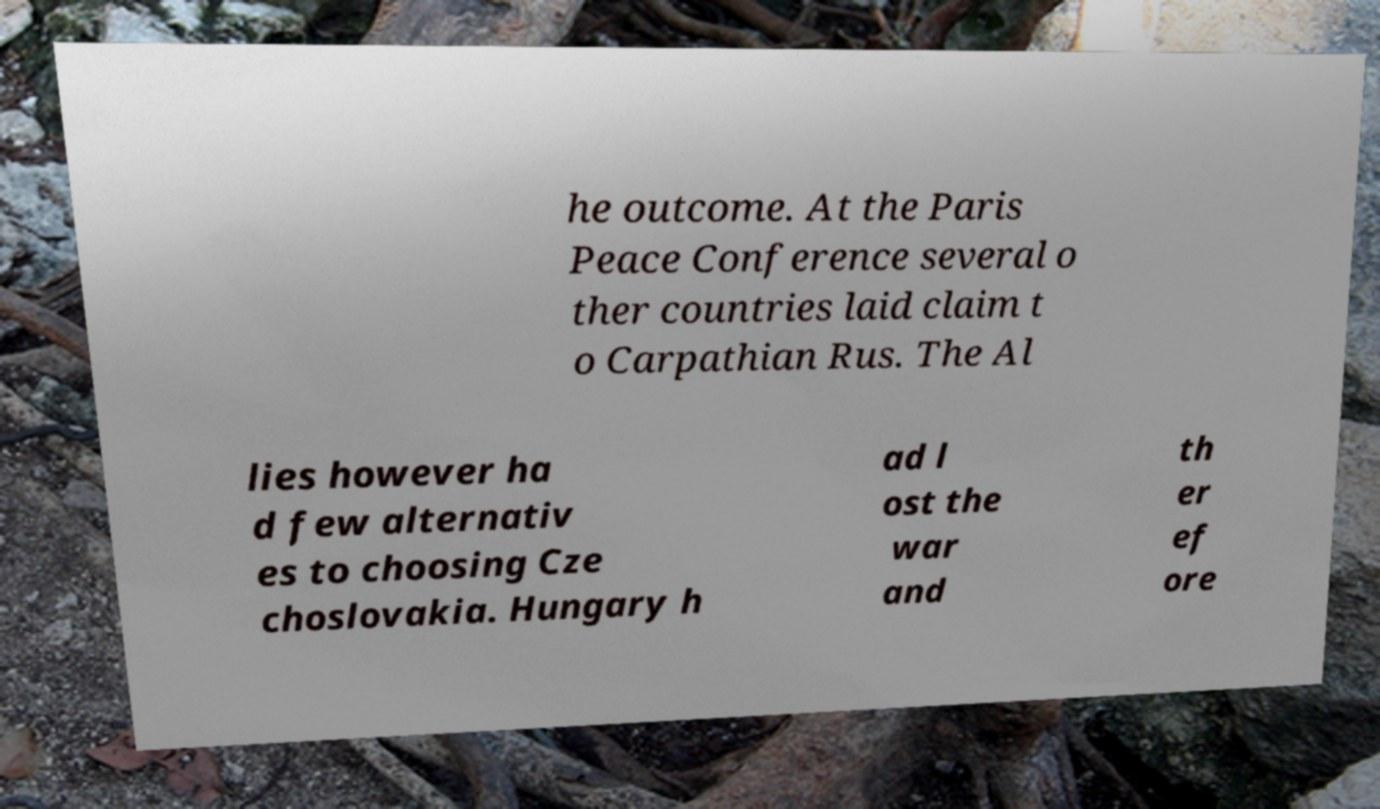For documentation purposes, I need the text within this image transcribed. Could you provide that? he outcome. At the Paris Peace Conference several o ther countries laid claim t o Carpathian Rus. The Al lies however ha d few alternativ es to choosing Cze choslovakia. Hungary h ad l ost the war and th er ef ore 